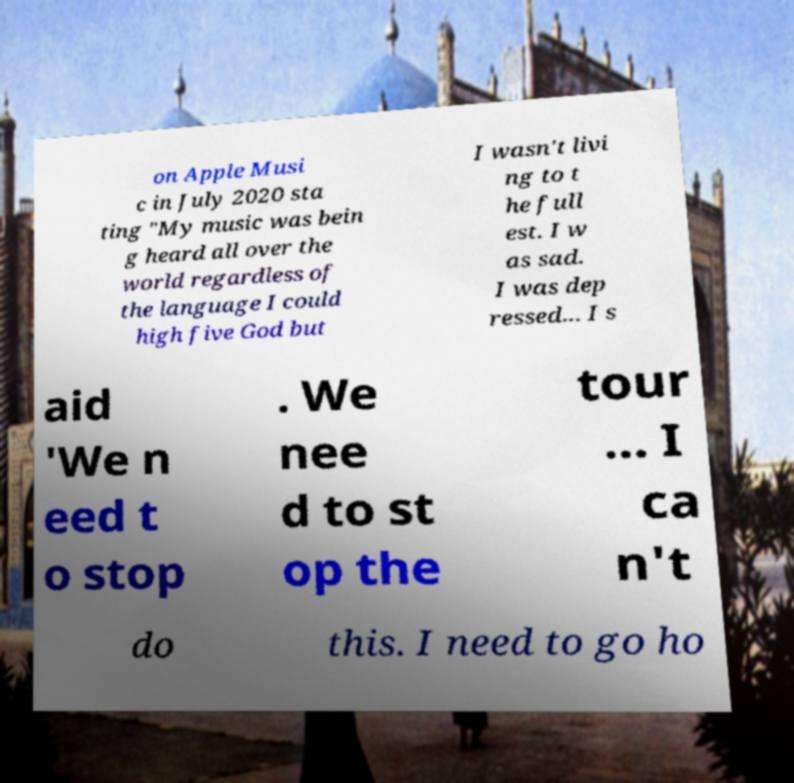I need the written content from this picture converted into text. Can you do that? on Apple Musi c in July 2020 sta ting "My music was bein g heard all over the world regardless of the language I could high five God but I wasn't livi ng to t he full est. I w as sad. I was dep ressed... I s aid 'We n eed t o stop . We nee d to st op the tour ... I ca n't do this. I need to go ho 